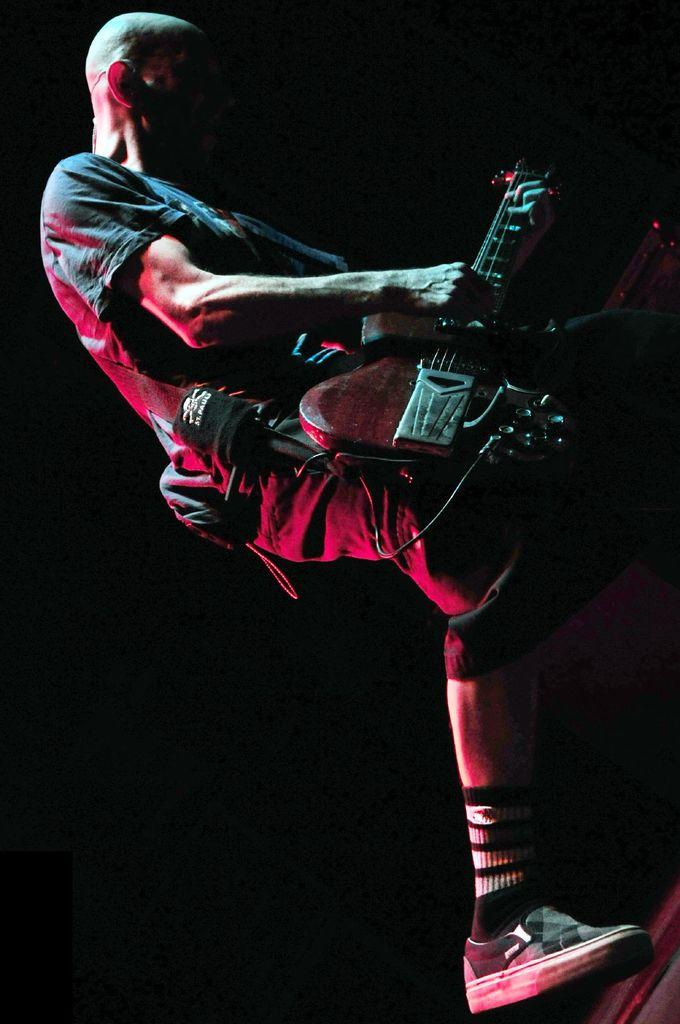Who is the main subject in the image? There is a man in the image. What is the man doing in the image? The man is standing and playing a guitar. What can be observed about the background of the image? The background of the image is dark. What type of hammer is the doctor using to fix the beam in the image? There is no doctor, hammer, or beam present in the image. The man is playing a guitar in a dark background. 